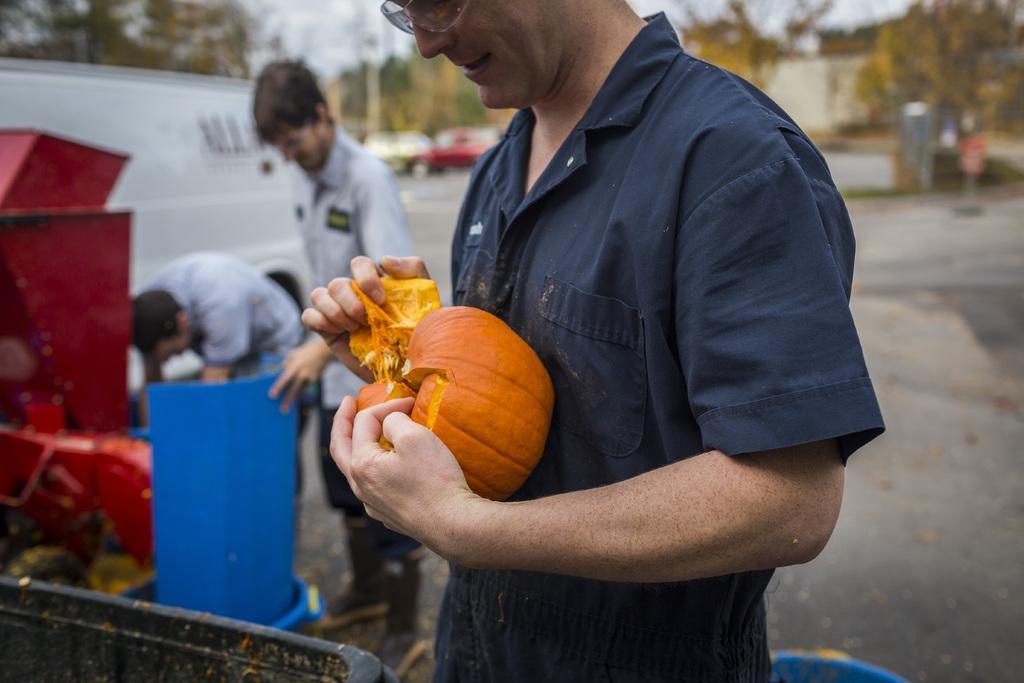Can you describe this image briefly? In the middle of the image few people are standing and holding something in the hands. Behind them we can see some trees, vehicles and poles. Background of the image is blur. 